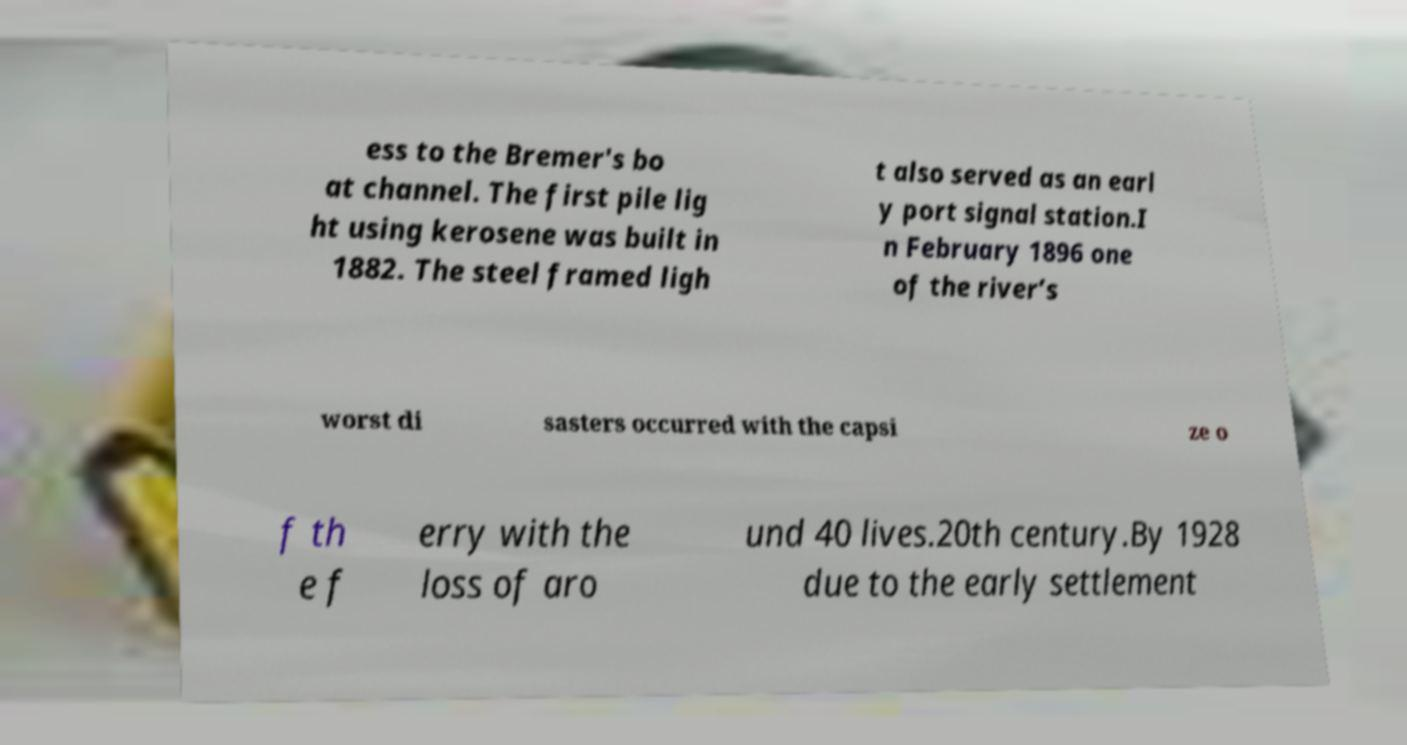Please identify and transcribe the text found in this image. ess to the Bremer's bo at channel. The first pile lig ht using kerosene was built in 1882. The steel framed ligh t also served as an earl y port signal station.I n February 1896 one of the river’s worst di sasters occurred with the capsi ze o f th e f erry with the loss of aro und 40 lives.20th century.By 1928 due to the early settlement 